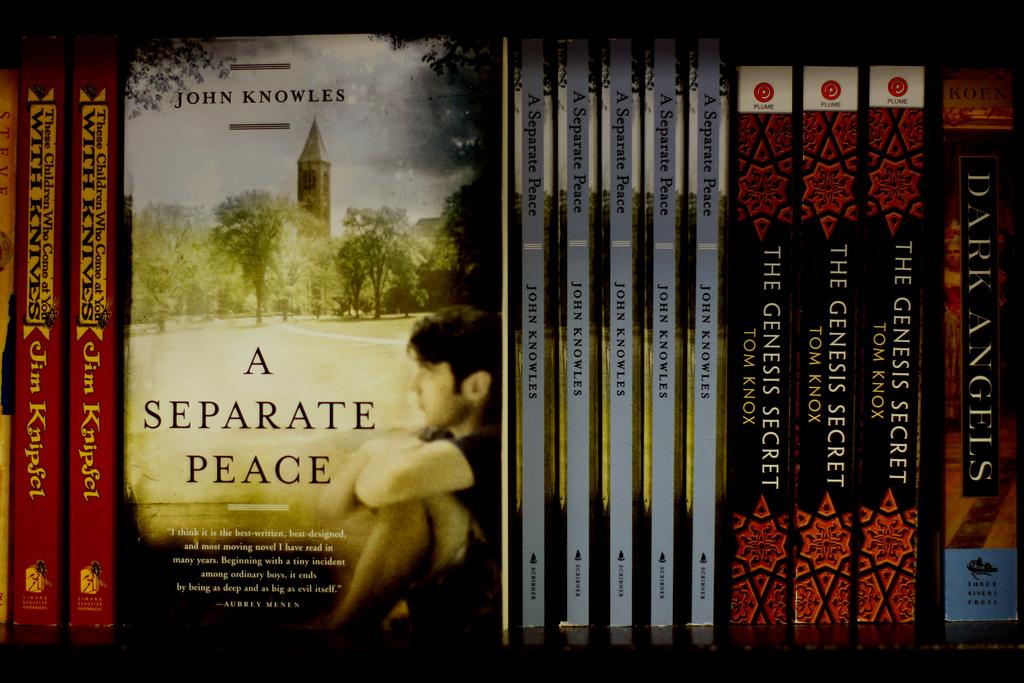Who wrote the book "a separate peace"?
Keep it short and to the point. John knowles. 